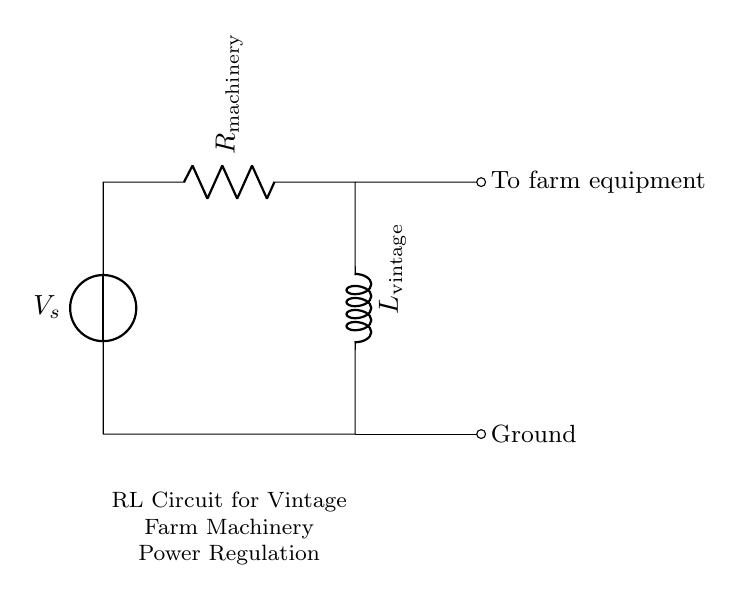What components are present in this circuit? The circuit contains a voltage source, a resistor labeled as machinery, and an inductor labeled as vintage. The voltage source provides power, the resistor controls the current, and the inductor stores energy in the magnetic field.
Answer: Voltage source, resistor, inductor What is the role of the resistor in this RL circuit? The resistor, labeled as machinery, limits the current flowing through the circuit, providing a way to regulate the power delivered to the vintage farm machinery. It also dissipates energy as heat.
Answer: Current limitation What is the function of the inductor in this circuit? The inductor, labeled as vintage, allows the circuit to store energy in its magnetic field. It also helps to smooth out fluctuations in current and can add inductive reactance to the circuit.
Answer: Energy storage What is the direction of current flow in this circuit? The current flows from the voltage source, passing through the resistor (machinery), then through the inductor (vintage), and finally returning to the voltage source. This is a closed-loop circuit.
Answer: Clockwise What effect does increasing resistance have on the RL circuit? Increasing the resistance will decrease the overall current in the circuit according to Ohm's Law, thus reducing the power delivered to the vintage farm machinery. It may also affect the time constant for charging and discharging the inductor.
Answer: Decreased current What is the initial current through the circuit when the voltage source is first applied? At the moment the voltage is first applied, the inductor initially opposes any change in current due to its property of inductance, resulting in zero current until the inductor begins to react to the applied voltage.
Answer: Zero How does this RL circuit contribute to vintage farm machinery restoration? The RL circuit helps regulate power, ensuring that vintage machinery receives stable and controlled energy, which prevents damage and enhances functionality during restoration.
Answer: Power regulation 